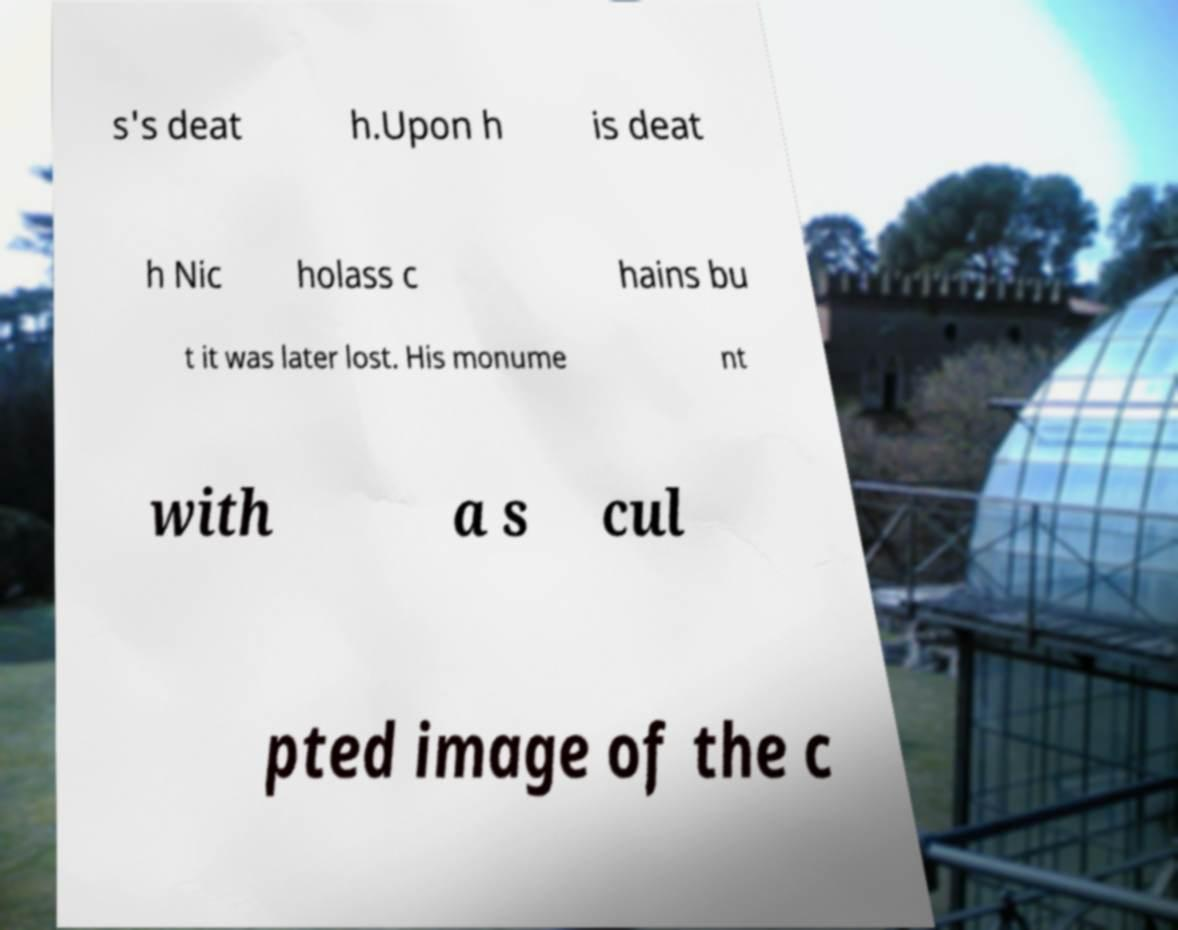For documentation purposes, I need the text within this image transcribed. Could you provide that? s's deat h.Upon h is deat h Nic holass c hains bu t it was later lost. His monume nt with a s cul pted image of the c 